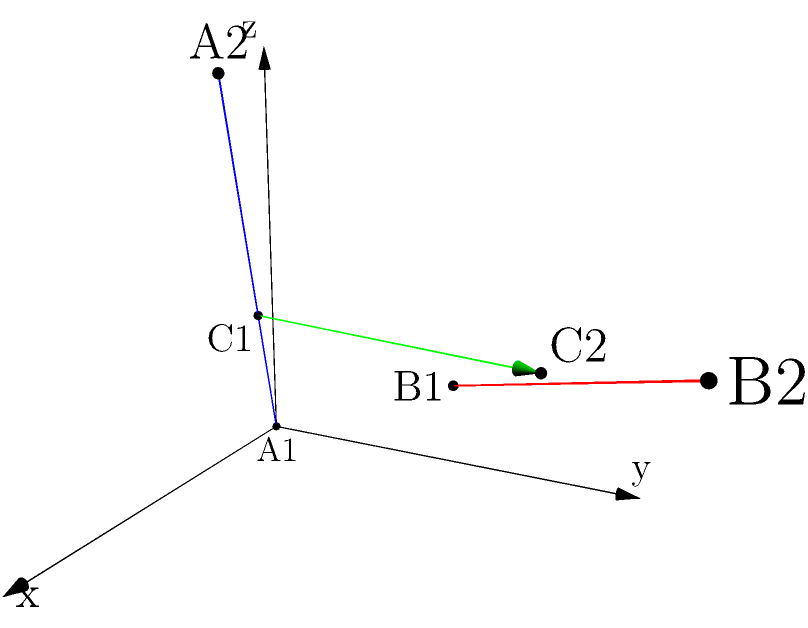Given two skew lines in 3D space:

Line A: passing through points $(0,0,0)$ and $(2,1,3)$
Line B: passing through points $(1,2,1)$ and $(3,4,2)$

Calculate the shortest distance between these two lines. To find the shortest distance between two skew lines, we can follow these steps:

1) First, let's define the direction vectors of the lines:
   $\vec{a} = (2-0, 1-0, 3-0) = (2, 1, 3)$
   $\vec{b} = (3-1, 4-2, 2-1) = (2, 2, 1)$

2) Now, we need to find a vector perpendicular to both lines. We can do this using the cross product:
   $\vec{n} = \vec{a} \times \vec{b} = (1\cdot1 - 3\cdot2, 3\cdot2 - 2\cdot1, 2\cdot2 - 1\cdot2) = (-5, 4, 2)$

3) Next, we need a vector connecting any point on line A to any point on line B. Let's use the given points:
   $\vec{c} = (1-0, 2-0, 1-0) = (1, 2, 1)$

4) The shortest distance will be the projection of $\vec{c}$ onto $\vec{n}$. We can calculate this using the formula:

   $d = \frac{|\vec{c} \cdot \vec{n}|}{|\vec{n}|}$

5) Let's calculate the dot product $\vec{c} \cdot \vec{n}$:
   $\vec{c} \cdot \vec{n} = 1(-5) + 2(4) + 1(2) = -5 + 8 + 2 = 5$

6) Now let's calculate $|\vec{n}|$:
   $|\vec{n}| = \sqrt{(-5)^2 + 4^2 + 2^2} = \sqrt{25 + 16 + 4} = \sqrt{45}$

7) Finally, we can calculate the shortest distance:
   $d = \frac{|5|}{\sqrt{45}} = \frac{5}{\sqrt{45}}$
Answer: $\frac{5}{\sqrt{45}}$ 